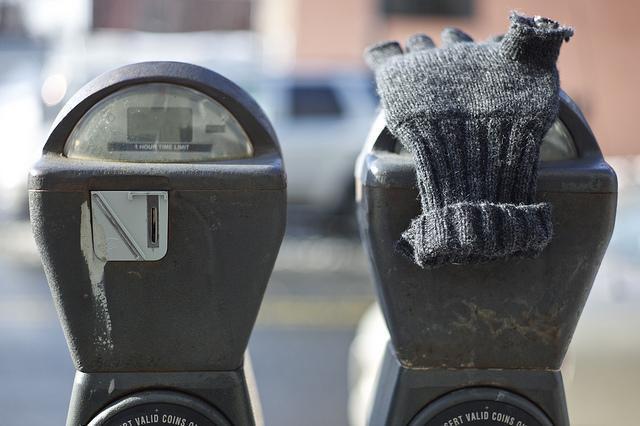What happens if you leave your car parked here an hour and a half?
Make your selection and explain in format: 'Answer: answer
Rationale: rationale.'
Options: Bulk rate, nothing, commendation, ticket. Answer: ticket.
Rationale: Staying in a parking spot too long will result in a ticket. 